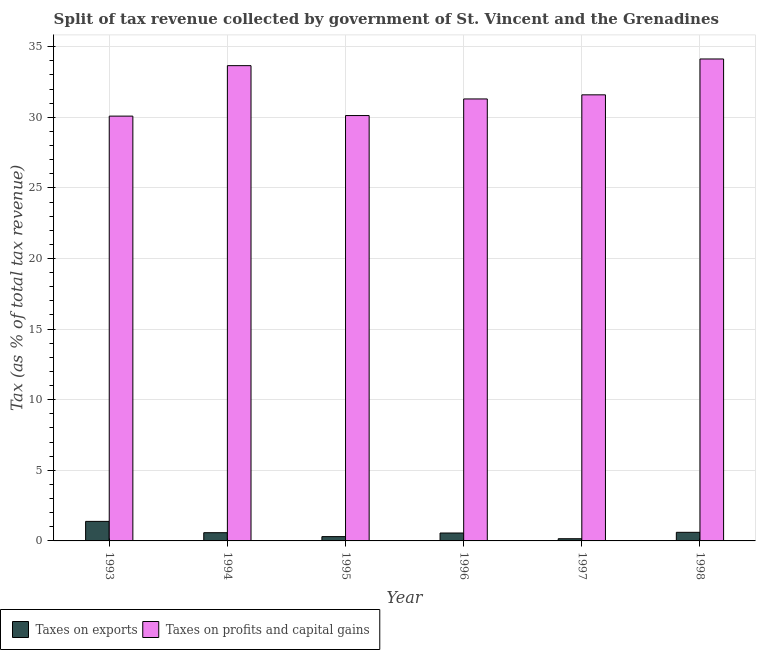How many groups of bars are there?
Your answer should be very brief. 6. Are the number of bars on each tick of the X-axis equal?
Keep it short and to the point. Yes. How many bars are there on the 2nd tick from the right?
Your response must be concise. 2. What is the label of the 6th group of bars from the left?
Keep it short and to the point. 1998. What is the percentage of revenue obtained from taxes on exports in 1995?
Your answer should be very brief. 0.3. Across all years, what is the maximum percentage of revenue obtained from taxes on profits and capital gains?
Keep it short and to the point. 34.13. Across all years, what is the minimum percentage of revenue obtained from taxes on profits and capital gains?
Ensure brevity in your answer.  30.08. In which year was the percentage of revenue obtained from taxes on exports maximum?
Ensure brevity in your answer.  1993. What is the total percentage of revenue obtained from taxes on exports in the graph?
Offer a very short reply. 3.59. What is the difference between the percentage of revenue obtained from taxes on exports in 1995 and that in 1998?
Offer a very short reply. -0.3. What is the difference between the percentage of revenue obtained from taxes on exports in 1998 and the percentage of revenue obtained from taxes on profits and capital gains in 1993?
Offer a very short reply. -0.77. What is the average percentage of revenue obtained from taxes on exports per year?
Provide a succinct answer. 0.6. In the year 1993, what is the difference between the percentage of revenue obtained from taxes on profits and capital gains and percentage of revenue obtained from taxes on exports?
Give a very brief answer. 0. In how many years, is the percentage of revenue obtained from taxes on exports greater than 17 %?
Your answer should be very brief. 0. What is the ratio of the percentage of revenue obtained from taxes on exports in 1994 to that in 1998?
Your response must be concise. 0.96. Is the percentage of revenue obtained from taxes on profits and capital gains in 1995 less than that in 1998?
Your answer should be very brief. Yes. What is the difference between the highest and the second highest percentage of revenue obtained from taxes on exports?
Provide a short and direct response. 0.77. What is the difference between the highest and the lowest percentage of revenue obtained from taxes on profits and capital gains?
Your response must be concise. 4.05. In how many years, is the percentage of revenue obtained from taxes on profits and capital gains greater than the average percentage of revenue obtained from taxes on profits and capital gains taken over all years?
Ensure brevity in your answer.  2. Is the sum of the percentage of revenue obtained from taxes on exports in 1995 and 1998 greater than the maximum percentage of revenue obtained from taxes on profits and capital gains across all years?
Ensure brevity in your answer.  No. What does the 2nd bar from the left in 1995 represents?
Ensure brevity in your answer.  Taxes on profits and capital gains. What does the 2nd bar from the right in 1996 represents?
Ensure brevity in your answer.  Taxes on exports. Are all the bars in the graph horizontal?
Make the answer very short. No. What is the difference between two consecutive major ticks on the Y-axis?
Your answer should be very brief. 5. Are the values on the major ticks of Y-axis written in scientific E-notation?
Give a very brief answer. No. Does the graph contain any zero values?
Make the answer very short. No. Does the graph contain grids?
Your answer should be compact. Yes. Where does the legend appear in the graph?
Your response must be concise. Bottom left. What is the title of the graph?
Your response must be concise. Split of tax revenue collected by government of St. Vincent and the Grenadines. Does "Constant 2005 US$" appear as one of the legend labels in the graph?
Give a very brief answer. No. What is the label or title of the Y-axis?
Provide a short and direct response. Tax (as % of total tax revenue). What is the Tax (as % of total tax revenue) of Taxes on exports in 1993?
Your answer should be compact. 1.38. What is the Tax (as % of total tax revenue) in Taxes on profits and capital gains in 1993?
Your answer should be very brief. 30.08. What is the Tax (as % of total tax revenue) of Taxes on exports in 1994?
Your answer should be very brief. 0.58. What is the Tax (as % of total tax revenue) of Taxes on profits and capital gains in 1994?
Your response must be concise. 33.66. What is the Tax (as % of total tax revenue) of Taxes on exports in 1995?
Provide a short and direct response. 0.3. What is the Tax (as % of total tax revenue) of Taxes on profits and capital gains in 1995?
Keep it short and to the point. 30.12. What is the Tax (as % of total tax revenue) in Taxes on exports in 1996?
Ensure brevity in your answer.  0.56. What is the Tax (as % of total tax revenue) in Taxes on profits and capital gains in 1996?
Provide a short and direct response. 31.3. What is the Tax (as % of total tax revenue) in Taxes on exports in 1997?
Keep it short and to the point. 0.16. What is the Tax (as % of total tax revenue) of Taxes on profits and capital gains in 1997?
Your response must be concise. 31.59. What is the Tax (as % of total tax revenue) in Taxes on exports in 1998?
Ensure brevity in your answer.  0.61. What is the Tax (as % of total tax revenue) of Taxes on profits and capital gains in 1998?
Keep it short and to the point. 34.13. Across all years, what is the maximum Tax (as % of total tax revenue) of Taxes on exports?
Keep it short and to the point. 1.38. Across all years, what is the maximum Tax (as % of total tax revenue) in Taxes on profits and capital gains?
Your answer should be very brief. 34.13. Across all years, what is the minimum Tax (as % of total tax revenue) of Taxes on exports?
Ensure brevity in your answer.  0.16. Across all years, what is the minimum Tax (as % of total tax revenue) of Taxes on profits and capital gains?
Offer a terse response. 30.08. What is the total Tax (as % of total tax revenue) in Taxes on exports in the graph?
Provide a succinct answer. 3.59. What is the total Tax (as % of total tax revenue) in Taxes on profits and capital gains in the graph?
Make the answer very short. 190.88. What is the difference between the Tax (as % of total tax revenue) in Taxes on exports in 1993 and that in 1994?
Ensure brevity in your answer.  0.8. What is the difference between the Tax (as % of total tax revenue) of Taxes on profits and capital gains in 1993 and that in 1994?
Make the answer very short. -3.57. What is the difference between the Tax (as % of total tax revenue) of Taxes on exports in 1993 and that in 1995?
Your answer should be compact. 1.08. What is the difference between the Tax (as % of total tax revenue) of Taxes on profits and capital gains in 1993 and that in 1995?
Your answer should be compact. -0.04. What is the difference between the Tax (as % of total tax revenue) of Taxes on exports in 1993 and that in 1996?
Keep it short and to the point. 0.82. What is the difference between the Tax (as % of total tax revenue) in Taxes on profits and capital gains in 1993 and that in 1996?
Make the answer very short. -1.22. What is the difference between the Tax (as % of total tax revenue) of Taxes on exports in 1993 and that in 1997?
Ensure brevity in your answer.  1.23. What is the difference between the Tax (as % of total tax revenue) of Taxes on profits and capital gains in 1993 and that in 1997?
Provide a short and direct response. -1.51. What is the difference between the Tax (as % of total tax revenue) of Taxes on exports in 1993 and that in 1998?
Give a very brief answer. 0.77. What is the difference between the Tax (as % of total tax revenue) in Taxes on profits and capital gains in 1993 and that in 1998?
Provide a succinct answer. -4.05. What is the difference between the Tax (as % of total tax revenue) in Taxes on exports in 1994 and that in 1995?
Offer a very short reply. 0.28. What is the difference between the Tax (as % of total tax revenue) in Taxes on profits and capital gains in 1994 and that in 1995?
Your answer should be very brief. 3.54. What is the difference between the Tax (as % of total tax revenue) in Taxes on exports in 1994 and that in 1996?
Your answer should be compact. 0.02. What is the difference between the Tax (as % of total tax revenue) of Taxes on profits and capital gains in 1994 and that in 1996?
Offer a terse response. 2.36. What is the difference between the Tax (as % of total tax revenue) of Taxes on exports in 1994 and that in 1997?
Keep it short and to the point. 0.43. What is the difference between the Tax (as % of total tax revenue) of Taxes on profits and capital gains in 1994 and that in 1997?
Provide a succinct answer. 2.07. What is the difference between the Tax (as % of total tax revenue) of Taxes on exports in 1994 and that in 1998?
Offer a very short reply. -0.03. What is the difference between the Tax (as % of total tax revenue) of Taxes on profits and capital gains in 1994 and that in 1998?
Make the answer very short. -0.47. What is the difference between the Tax (as % of total tax revenue) in Taxes on exports in 1995 and that in 1996?
Offer a very short reply. -0.26. What is the difference between the Tax (as % of total tax revenue) in Taxes on profits and capital gains in 1995 and that in 1996?
Your answer should be compact. -1.18. What is the difference between the Tax (as % of total tax revenue) of Taxes on exports in 1995 and that in 1997?
Make the answer very short. 0.15. What is the difference between the Tax (as % of total tax revenue) of Taxes on profits and capital gains in 1995 and that in 1997?
Offer a very short reply. -1.47. What is the difference between the Tax (as % of total tax revenue) of Taxes on exports in 1995 and that in 1998?
Ensure brevity in your answer.  -0.3. What is the difference between the Tax (as % of total tax revenue) in Taxes on profits and capital gains in 1995 and that in 1998?
Give a very brief answer. -4.01. What is the difference between the Tax (as % of total tax revenue) of Taxes on exports in 1996 and that in 1997?
Your answer should be very brief. 0.4. What is the difference between the Tax (as % of total tax revenue) in Taxes on profits and capital gains in 1996 and that in 1997?
Provide a short and direct response. -0.29. What is the difference between the Tax (as % of total tax revenue) of Taxes on exports in 1996 and that in 1998?
Provide a succinct answer. -0.05. What is the difference between the Tax (as % of total tax revenue) in Taxes on profits and capital gains in 1996 and that in 1998?
Ensure brevity in your answer.  -2.83. What is the difference between the Tax (as % of total tax revenue) in Taxes on exports in 1997 and that in 1998?
Provide a short and direct response. -0.45. What is the difference between the Tax (as % of total tax revenue) of Taxes on profits and capital gains in 1997 and that in 1998?
Your answer should be compact. -2.54. What is the difference between the Tax (as % of total tax revenue) of Taxes on exports in 1993 and the Tax (as % of total tax revenue) of Taxes on profits and capital gains in 1994?
Provide a succinct answer. -32.27. What is the difference between the Tax (as % of total tax revenue) of Taxes on exports in 1993 and the Tax (as % of total tax revenue) of Taxes on profits and capital gains in 1995?
Provide a short and direct response. -28.74. What is the difference between the Tax (as % of total tax revenue) of Taxes on exports in 1993 and the Tax (as % of total tax revenue) of Taxes on profits and capital gains in 1996?
Provide a short and direct response. -29.92. What is the difference between the Tax (as % of total tax revenue) of Taxes on exports in 1993 and the Tax (as % of total tax revenue) of Taxes on profits and capital gains in 1997?
Keep it short and to the point. -30.21. What is the difference between the Tax (as % of total tax revenue) in Taxes on exports in 1993 and the Tax (as % of total tax revenue) in Taxes on profits and capital gains in 1998?
Your answer should be compact. -32.75. What is the difference between the Tax (as % of total tax revenue) of Taxes on exports in 1994 and the Tax (as % of total tax revenue) of Taxes on profits and capital gains in 1995?
Your answer should be very brief. -29.54. What is the difference between the Tax (as % of total tax revenue) of Taxes on exports in 1994 and the Tax (as % of total tax revenue) of Taxes on profits and capital gains in 1996?
Offer a very short reply. -30.72. What is the difference between the Tax (as % of total tax revenue) of Taxes on exports in 1994 and the Tax (as % of total tax revenue) of Taxes on profits and capital gains in 1997?
Provide a short and direct response. -31.01. What is the difference between the Tax (as % of total tax revenue) of Taxes on exports in 1994 and the Tax (as % of total tax revenue) of Taxes on profits and capital gains in 1998?
Your response must be concise. -33.55. What is the difference between the Tax (as % of total tax revenue) of Taxes on exports in 1995 and the Tax (as % of total tax revenue) of Taxes on profits and capital gains in 1996?
Your answer should be compact. -30.99. What is the difference between the Tax (as % of total tax revenue) of Taxes on exports in 1995 and the Tax (as % of total tax revenue) of Taxes on profits and capital gains in 1997?
Your response must be concise. -31.29. What is the difference between the Tax (as % of total tax revenue) of Taxes on exports in 1995 and the Tax (as % of total tax revenue) of Taxes on profits and capital gains in 1998?
Your answer should be very brief. -33.82. What is the difference between the Tax (as % of total tax revenue) in Taxes on exports in 1996 and the Tax (as % of total tax revenue) in Taxes on profits and capital gains in 1997?
Keep it short and to the point. -31.03. What is the difference between the Tax (as % of total tax revenue) in Taxes on exports in 1996 and the Tax (as % of total tax revenue) in Taxes on profits and capital gains in 1998?
Keep it short and to the point. -33.57. What is the difference between the Tax (as % of total tax revenue) in Taxes on exports in 1997 and the Tax (as % of total tax revenue) in Taxes on profits and capital gains in 1998?
Provide a short and direct response. -33.97. What is the average Tax (as % of total tax revenue) of Taxes on exports per year?
Make the answer very short. 0.6. What is the average Tax (as % of total tax revenue) of Taxes on profits and capital gains per year?
Ensure brevity in your answer.  31.81. In the year 1993, what is the difference between the Tax (as % of total tax revenue) of Taxes on exports and Tax (as % of total tax revenue) of Taxes on profits and capital gains?
Make the answer very short. -28.7. In the year 1994, what is the difference between the Tax (as % of total tax revenue) of Taxes on exports and Tax (as % of total tax revenue) of Taxes on profits and capital gains?
Offer a terse response. -33.07. In the year 1995, what is the difference between the Tax (as % of total tax revenue) in Taxes on exports and Tax (as % of total tax revenue) in Taxes on profits and capital gains?
Offer a very short reply. -29.82. In the year 1996, what is the difference between the Tax (as % of total tax revenue) in Taxes on exports and Tax (as % of total tax revenue) in Taxes on profits and capital gains?
Provide a short and direct response. -30.74. In the year 1997, what is the difference between the Tax (as % of total tax revenue) in Taxes on exports and Tax (as % of total tax revenue) in Taxes on profits and capital gains?
Provide a succinct answer. -31.43. In the year 1998, what is the difference between the Tax (as % of total tax revenue) of Taxes on exports and Tax (as % of total tax revenue) of Taxes on profits and capital gains?
Ensure brevity in your answer.  -33.52. What is the ratio of the Tax (as % of total tax revenue) of Taxes on exports in 1993 to that in 1994?
Provide a short and direct response. 2.37. What is the ratio of the Tax (as % of total tax revenue) of Taxes on profits and capital gains in 1993 to that in 1994?
Offer a terse response. 0.89. What is the ratio of the Tax (as % of total tax revenue) of Taxes on exports in 1993 to that in 1995?
Provide a short and direct response. 4.54. What is the ratio of the Tax (as % of total tax revenue) of Taxes on profits and capital gains in 1993 to that in 1995?
Your response must be concise. 1. What is the ratio of the Tax (as % of total tax revenue) of Taxes on exports in 1993 to that in 1996?
Your answer should be very brief. 2.47. What is the ratio of the Tax (as % of total tax revenue) of Taxes on profits and capital gains in 1993 to that in 1996?
Ensure brevity in your answer.  0.96. What is the ratio of the Tax (as % of total tax revenue) in Taxes on exports in 1993 to that in 1997?
Your response must be concise. 8.9. What is the ratio of the Tax (as % of total tax revenue) in Taxes on profits and capital gains in 1993 to that in 1997?
Offer a very short reply. 0.95. What is the ratio of the Tax (as % of total tax revenue) in Taxes on exports in 1993 to that in 1998?
Your answer should be very brief. 2.27. What is the ratio of the Tax (as % of total tax revenue) in Taxes on profits and capital gains in 1993 to that in 1998?
Offer a very short reply. 0.88. What is the ratio of the Tax (as % of total tax revenue) of Taxes on exports in 1994 to that in 1995?
Your response must be concise. 1.91. What is the ratio of the Tax (as % of total tax revenue) of Taxes on profits and capital gains in 1994 to that in 1995?
Provide a succinct answer. 1.12. What is the ratio of the Tax (as % of total tax revenue) of Taxes on exports in 1994 to that in 1996?
Make the answer very short. 1.04. What is the ratio of the Tax (as % of total tax revenue) of Taxes on profits and capital gains in 1994 to that in 1996?
Ensure brevity in your answer.  1.08. What is the ratio of the Tax (as % of total tax revenue) of Taxes on exports in 1994 to that in 1997?
Give a very brief answer. 3.75. What is the ratio of the Tax (as % of total tax revenue) in Taxes on profits and capital gains in 1994 to that in 1997?
Ensure brevity in your answer.  1.07. What is the ratio of the Tax (as % of total tax revenue) of Taxes on exports in 1994 to that in 1998?
Ensure brevity in your answer.  0.96. What is the ratio of the Tax (as % of total tax revenue) in Taxes on profits and capital gains in 1994 to that in 1998?
Your answer should be very brief. 0.99. What is the ratio of the Tax (as % of total tax revenue) of Taxes on exports in 1995 to that in 1996?
Offer a very short reply. 0.54. What is the ratio of the Tax (as % of total tax revenue) in Taxes on profits and capital gains in 1995 to that in 1996?
Provide a succinct answer. 0.96. What is the ratio of the Tax (as % of total tax revenue) in Taxes on exports in 1995 to that in 1997?
Your answer should be very brief. 1.96. What is the ratio of the Tax (as % of total tax revenue) in Taxes on profits and capital gains in 1995 to that in 1997?
Provide a succinct answer. 0.95. What is the ratio of the Tax (as % of total tax revenue) in Taxes on exports in 1995 to that in 1998?
Your answer should be very brief. 0.5. What is the ratio of the Tax (as % of total tax revenue) in Taxes on profits and capital gains in 1995 to that in 1998?
Make the answer very short. 0.88. What is the ratio of the Tax (as % of total tax revenue) in Taxes on exports in 1996 to that in 1997?
Make the answer very short. 3.6. What is the ratio of the Tax (as % of total tax revenue) of Taxes on profits and capital gains in 1996 to that in 1998?
Provide a succinct answer. 0.92. What is the ratio of the Tax (as % of total tax revenue) of Taxes on exports in 1997 to that in 1998?
Your answer should be very brief. 0.26. What is the ratio of the Tax (as % of total tax revenue) of Taxes on profits and capital gains in 1997 to that in 1998?
Your response must be concise. 0.93. What is the difference between the highest and the second highest Tax (as % of total tax revenue) in Taxes on exports?
Your answer should be very brief. 0.77. What is the difference between the highest and the second highest Tax (as % of total tax revenue) of Taxes on profits and capital gains?
Give a very brief answer. 0.47. What is the difference between the highest and the lowest Tax (as % of total tax revenue) in Taxes on exports?
Provide a succinct answer. 1.23. What is the difference between the highest and the lowest Tax (as % of total tax revenue) in Taxes on profits and capital gains?
Your answer should be compact. 4.05. 